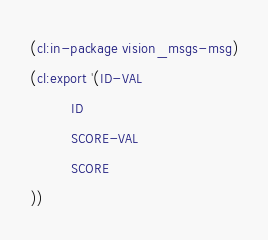Convert code to text. <code><loc_0><loc_0><loc_500><loc_500><_Lisp_>(cl:in-package vision_msgs-msg)
(cl:export '(ID-VAL
          ID
          SCORE-VAL
          SCORE
))</code> 